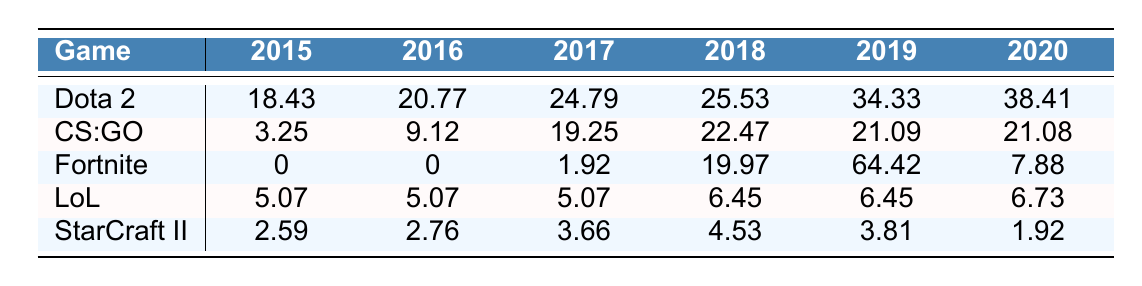What was the highest prize pool for Dota 2 in the given years? The highest prize pool for Dota 2 is in 2020, which is 38.41 million.
Answer: 38.41 million In which year did Fortnite have its highest prize pool? Fortnite's highest prize pool occurred in 2019, where it reached 64.42 million.
Answer: 2019 What was the total prize pool for League of Legends over the years 2015 to 2020? Summing the prize pools for League of Legends: 5.07 + 5.07 + 5.07 + 6.45 + 6.45 + 6.73 = 34.84 million.
Answer: 34.84 million Did Counter-Strike: Global Offensive's prize pool decrease from 2019 to 2020? Yes, it decreased from 21.09 million in 2019 to 21.08 million in 2020.
Answer: Yes What is the difference in prize pool between Dota 2 in 2018 and League of Legends in 2018? The difference is calculated as 25.53 (Dota 2 in 2018) - 6.45 (League of Legends in 2018) = 19.08 million.
Answer: 19.08 million What game had the lowest prize pool in 2015? In 2015, Fortnite had the lowest prize pool, which was 0.
Answer: Fortnite What was the average prize pool for StarCraft II over the years? The average prize pool for StarCraft II is calculated as (2.59 + 2.76 + 3.66 + 4.53 + 3.81 + 1.92) / 6 = 2.95 million.
Answer: 2.95 million Which game saw the most significant increase in prize pool from 2017 to 2018? The prize pool for Fortnite increased the most, from 1.92 million in 2017 to 19.97 million in 2018, an increase of 18.05 million.
Answer: Fortnite Did any game have a consistently rising prize pool from 2015 to 2020? Yes, Dota 2 has a consistently rising prize pool every year from 2015 to 2020.
Answer: Yes Which game had the highest prize pool in 2019 and what was it? Fortnite had the highest prize pool in 2019, amounting to 64.42 million.
Answer: 64.42 million 